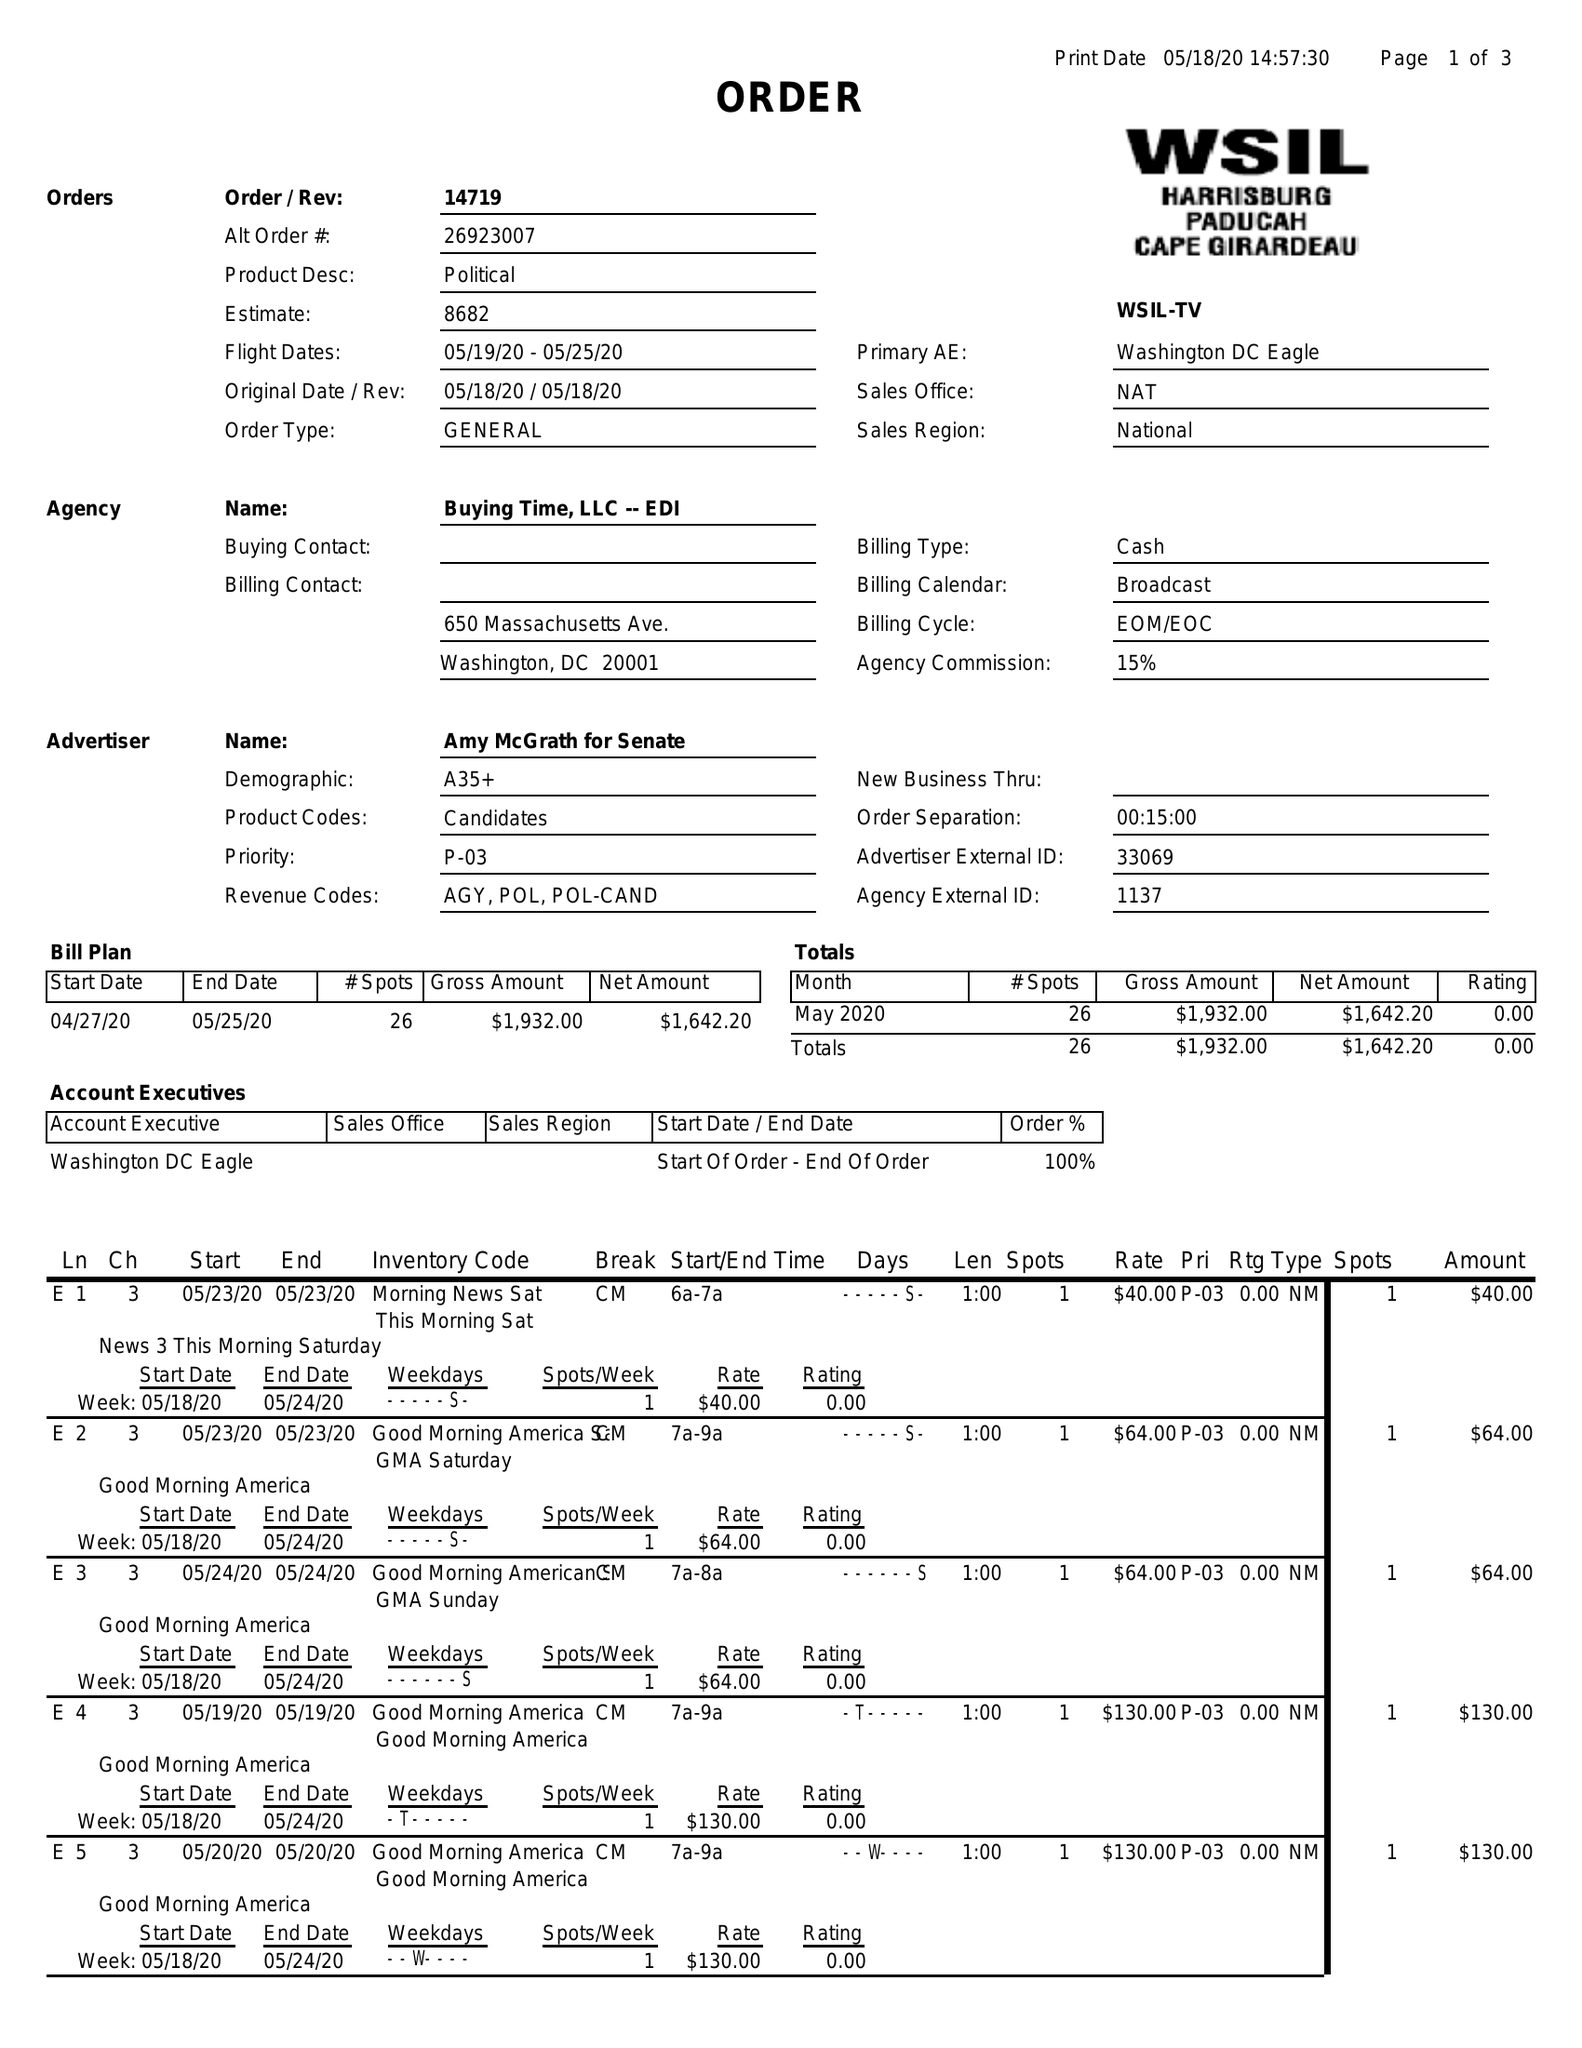What is the value for the flight_from?
Answer the question using a single word or phrase. 05/19/20 